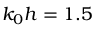<formula> <loc_0><loc_0><loc_500><loc_500>k _ { 0 } h = 1 . 5</formula> 